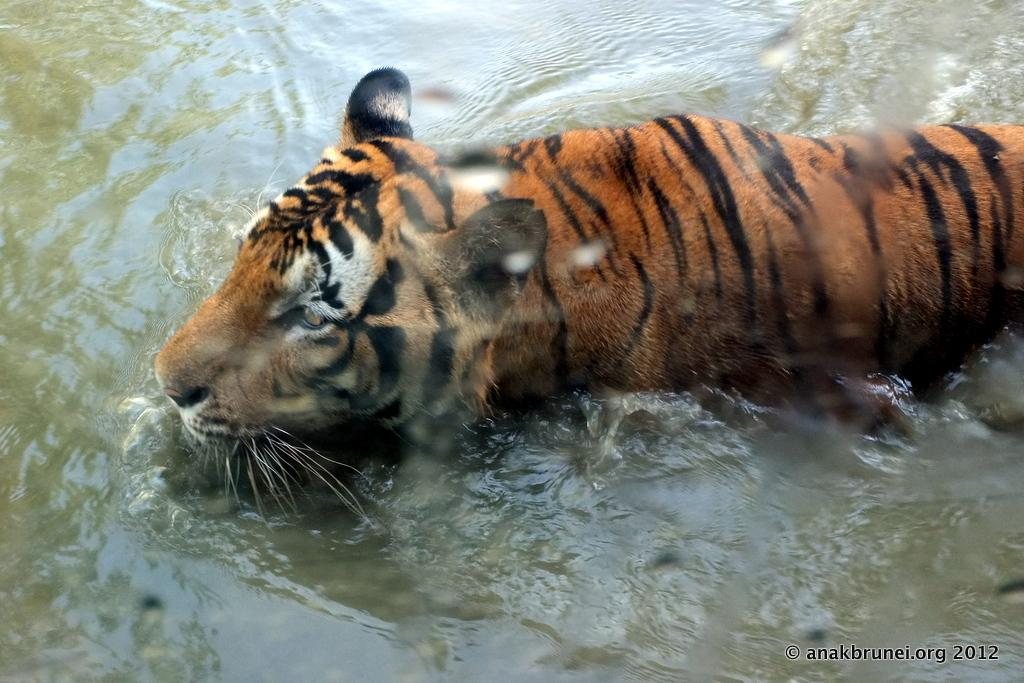What animal is present in the image? There is a tiger in the image. What is the tiger doing in the image? The tiger is walking in the water. What type of environment is depicted in the image? There is water visible in the image. What type of wood is the tiger using to build a club in the image? There is no wood or club present in the image; it features a tiger walking in the water. What shape is the tiger's tail in the image? The image does not provide enough detail to determine the shape of the tiger's tail. 